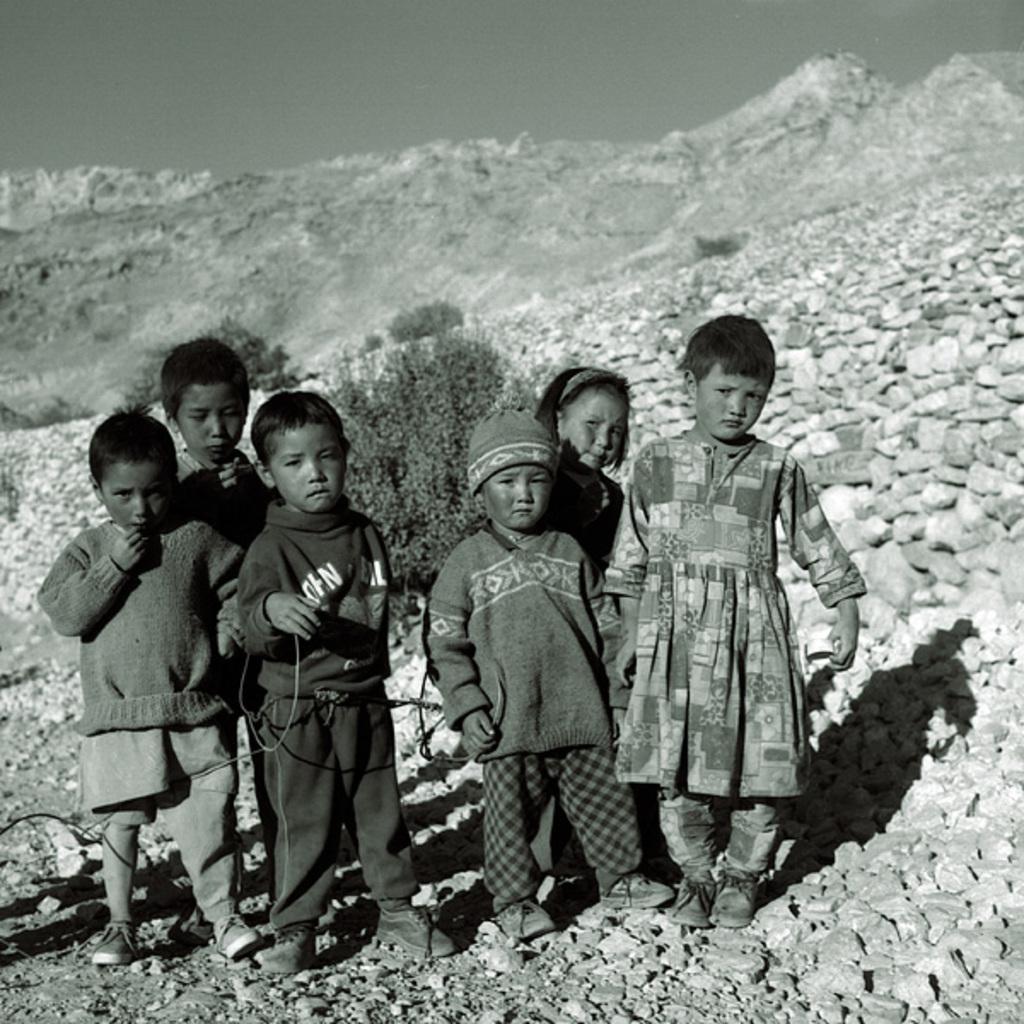Can you describe this image briefly? In this picture I can see few kids standing and I can see a boy wore a cap on his head and a hill and I can see few stones and plants on the ground. 